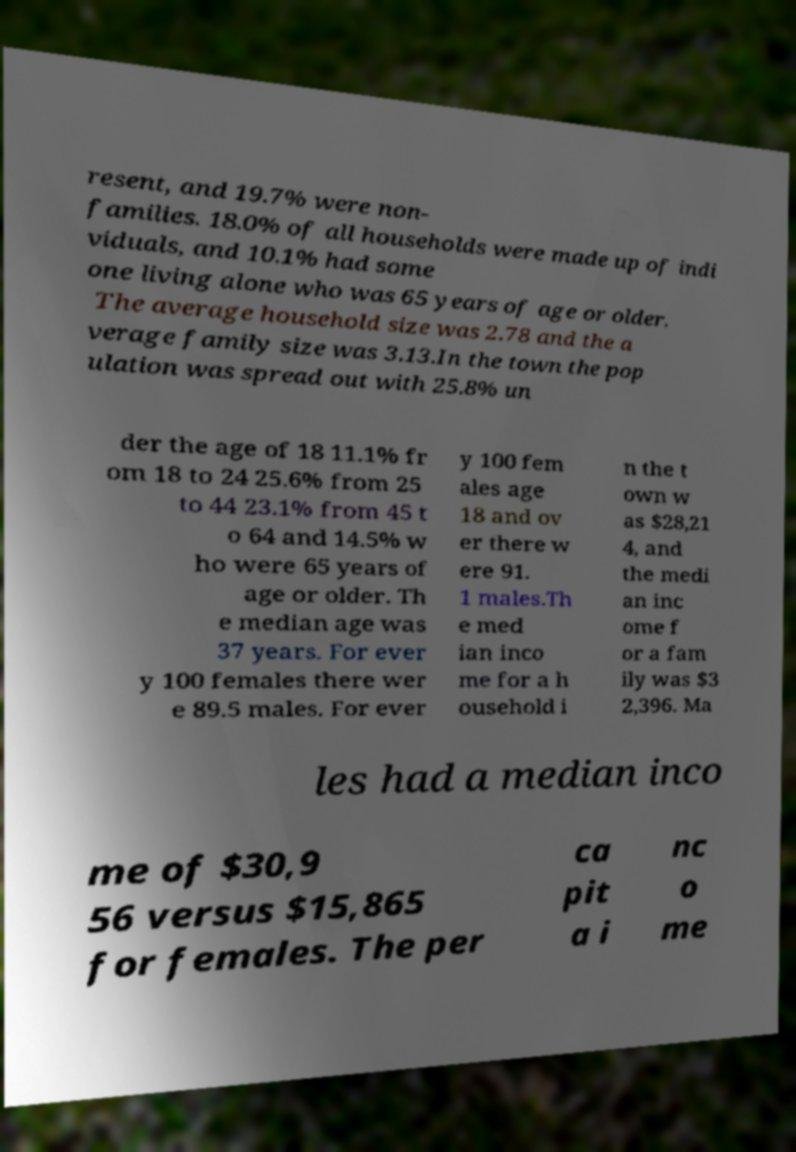Can you accurately transcribe the text from the provided image for me? resent, and 19.7% were non- families. 18.0% of all households were made up of indi viduals, and 10.1% had some one living alone who was 65 years of age or older. The average household size was 2.78 and the a verage family size was 3.13.In the town the pop ulation was spread out with 25.8% un der the age of 18 11.1% fr om 18 to 24 25.6% from 25 to 44 23.1% from 45 t o 64 and 14.5% w ho were 65 years of age or older. Th e median age was 37 years. For ever y 100 females there wer e 89.5 males. For ever y 100 fem ales age 18 and ov er there w ere 91. 1 males.Th e med ian inco me for a h ousehold i n the t own w as $28,21 4, and the medi an inc ome f or a fam ily was $3 2,396. Ma les had a median inco me of $30,9 56 versus $15,865 for females. The per ca pit a i nc o me 